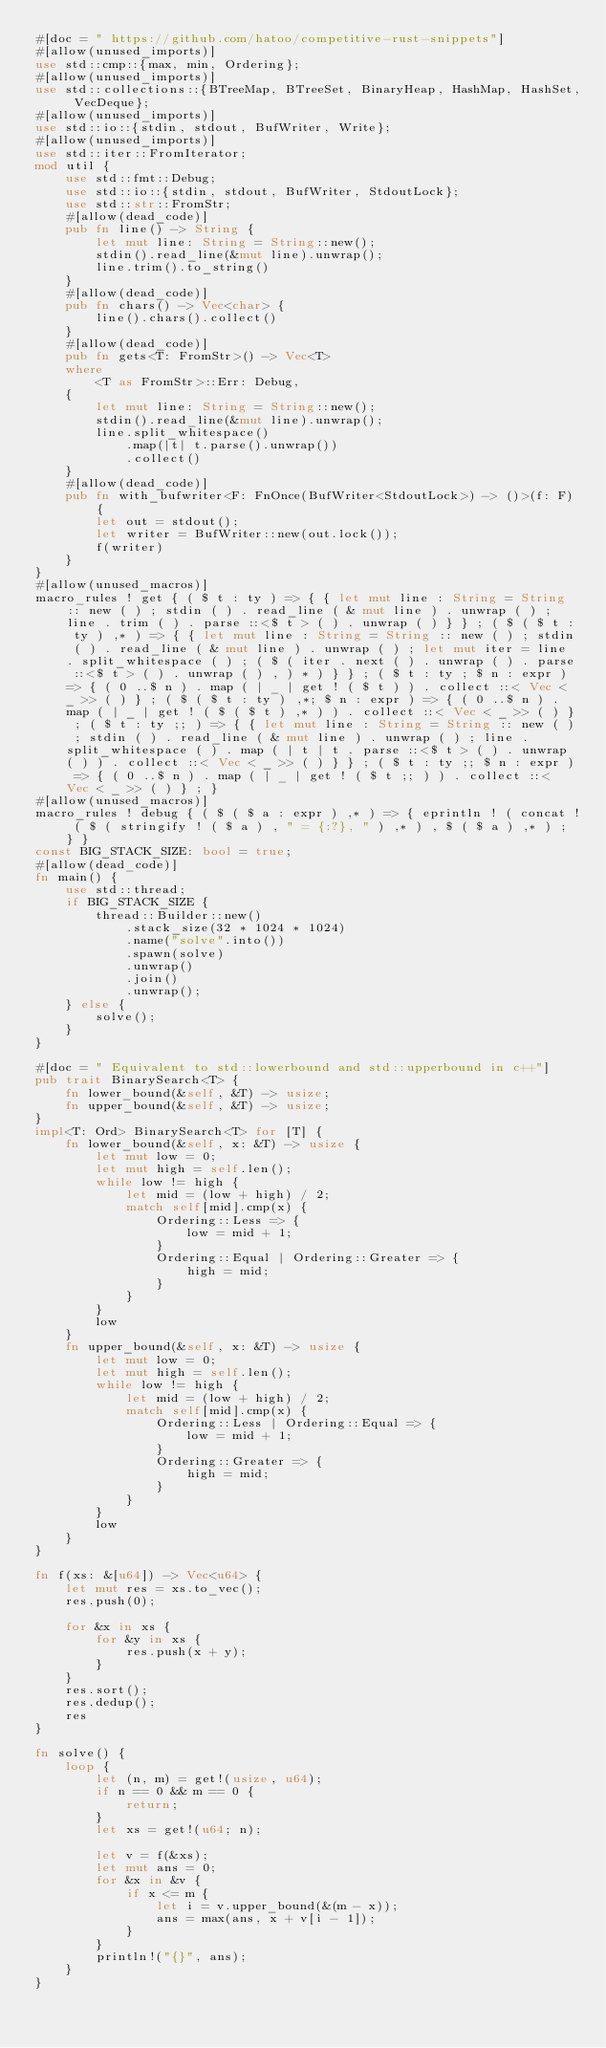Convert code to text. <code><loc_0><loc_0><loc_500><loc_500><_Rust_>#[doc = " https://github.com/hatoo/competitive-rust-snippets"]
#[allow(unused_imports)]
use std::cmp::{max, min, Ordering};
#[allow(unused_imports)]
use std::collections::{BTreeMap, BTreeSet, BinaryHeap, HashMap, HashSet, VecDeque};
#[allow(unused_imports)]
use std::io::{stdin, stdout, BufWriter, Write};
#[allow(unused_imports)]
use std::iter::FromIterator;
mod util {
    use std::fmt::Debug;
    use std::io::{stdin, stdout, BufWriter, StdoutLock};
    use std::str::FromStr;
    #[allow(dead_code)]
    pub fn line() -> String {
        let mut line: String = String::new();
        stdin().read_line(&mut line).unwrap();
        line.trim().to_string()
    }
    #[allow(dead_code)]
    pub fn chars() -> Vec<char> {
        line().chars().collect()
    }
    #[allow(dead_code)]
    pub fn gets<T: FromStr>() -> Vec<T>
    where
        <T as FromStr>::Err: Debug,
    {
        let mut line: String = String::new();
        stdin().read_line(&mut line).unwrap();
        line.split_whitespace()
            .map(|t| t.parse().unwrap())
            .collect()
    }
    #[allow(dead_code)]
    pub fn with_bufwriter<F: FnOnce(BufWriter<StdoutLock>) -> ()>(f: F) {
        let out = stdout();
        let writer = BufWriter::new(out.lock());
        f(writer)
    }
}
#[allow(unused_macros)]
macro_rules ! get { ( $ t : ty ) => { { let mut line : String = String :: new ( ) ; stdin ( ) . read_line ( & mut line ) . unwrap ( ) ; line . trim ( ) . parse ::<$ t > ( ) . unwrap ( ) } } ; ( $ ( $ t : ty ) ,* ) => { { let mut line : String = String :: new ( ) ; stdin ( ) . read_line ( & mut line ) . unwrap ( ) ; let mut iter = line . split_whitespace ( ) ; ( $ ( iter . next ( ) . unwrap ( ) . parse ::<$ t > ( ) . unwrap ( ) , ) * ) } } ; ( $ t : ty ; $ n : expr ) => { ( 0 ..$ n ) . map ( | _ | get ! ( $ t ) ) . collect ::< Vec < _ >> ( ) } ; ( $ ( $ t : ty ) ,*; $ n : expr ) => { ( 0 ..$ n ) . map ( | _ | get ! ( $ ( $ t ) ,* ) ) . collect ::< Vec < _ >> ( ) } ; ( $ t : ty ;; ) => { { let mut line : String = String :: new ( ) ; stdin ( ) . read_line ( & mut line ) . unwrap ( ) ; line . split_whitespace ( ) . map ( | t | t . parse ::<$ t > ( ) . unwrap ( ) ) . collect ::< Vec < _ >> ( ) } } ; ( $ t : ty ;; $ n : expr ) => { ( 0 ..$ n ) . map ( | _ | get ! ( $ t ;; ) ) . collect ::< Vec < _ >> ( ) } ; }
#[allow(unused_macros)]
macro_rules ! debug { ( $ ( $ a : expr ) ,* ) => { eprintln ! ( concat ! ( $ ( stringify ! ( $ a ) , " = {:?}, " ) ,* ) , $ ( $ a ) ,* ) ; } }
const BIG_STACK_SIZE: bool = true;
#[allow(dead_code)]
fn main() {
    use std::thread;
    if BIG_STACK_SIZE {
        thread::Builder::new()
            .stack_size(32 * 1024 * 1024)
            .name("solve".into())
            .spawn(solve)
            .unwrap()
            .join()
            .unwrap();
    } else {
        solve();
    }
}

#[doc = " Equivalent to std::lowerbound and std::upperbound in c++"]
pub trait BinarySearch<T> {
    fn lower_bound(&self, &T) -> usize;
    fn upper_bound(&self, &T) -> usize;
}
impl<T: Ord> BinarySearch<T> for [T] {
    fn lower_bound(&self, x: &T) -> usize {
        let mut low = 0;
        let mut high = self.len();
        while low != high {
            let mid = (low + high) / 2;
            match self[mid].cmp(x) {
                Ordering::Less => {
                    low = mid + 1;
                }
                Ordering::Equal | Ordering::Greater => {
                    high = mid;
                }
            }
        }
        low
    }
    fn upper_bound(&self, x: &T) -> usize {
        let mut low = 0;
        let mut high = self.len();
        while low != high {
            let mid = (low + high) / 2;
            match self[mid].cmp(x) {
                Ordering::Less | Ordering::Equal => {
                    low = mid + 1;
                }
                Ordering::Greater => {
                    high = mid;
                }
            }
        }
        low
    }
}

fn f(xs: &[u64]) -> Vec<u64> {
    let mut res = xs.to_vec();
    res.push(0);

    for &x in xs {
        for &y in xs {
            res.push(x + y);
        }
    }
    res.sort();
    res.dedup();
    res
}

fn solve() {
    loop {
        let (n, m) = get!(usize, u64);
        if n == 0 && m == 0 {
            return;
        }
        let xs = get!(u64; n);

        let v = f(&xs);
        let mut ans = 0;
        for &x in &v {
            if x <= m {
                let i = v.upper_bound(&(m - x));
                ans = max(ans, x + v[i - 1]);
            }
        }
        println!("{}", ans);
    }
}

</code> 